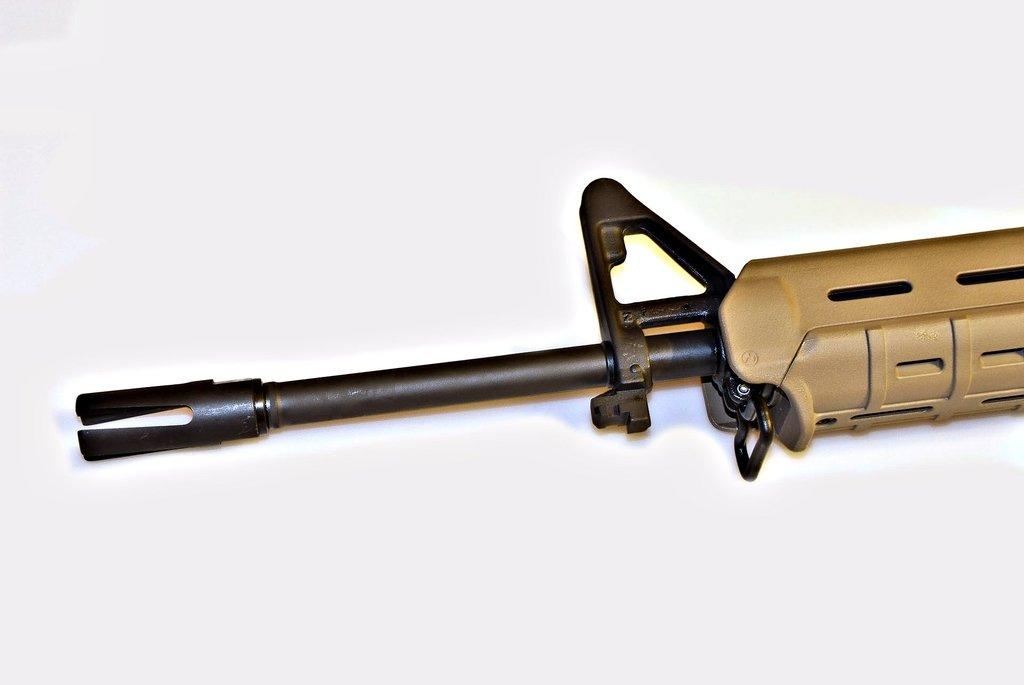What is the main subject of the image? The main subject of the image is a truncated picture of a gun. What color is the background of the image? The background of the image is white. What type of current can be seen flowing through the beads in the image? There are no beads or any indication of current in the image; it features a truncated picture of a gun with a white background. 